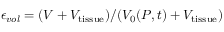<formula> <loc_0><loc_0><loc_500><loc_500>\epsilon _ { v o l } = ( V + V _ { t i s s u e } ) / ( V _ { 0 } ( P , t ) + V _ { t i s s u e } )</formula> 